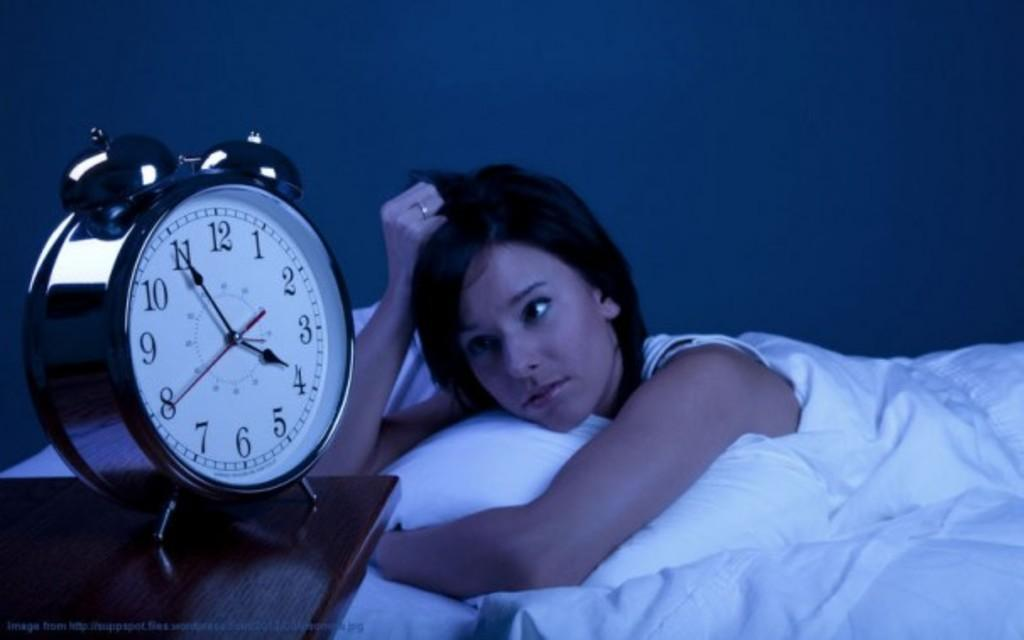<image>
Write a terse but informative summary of the picture. a clock on a desk displays 4:55 and 40 seconds 